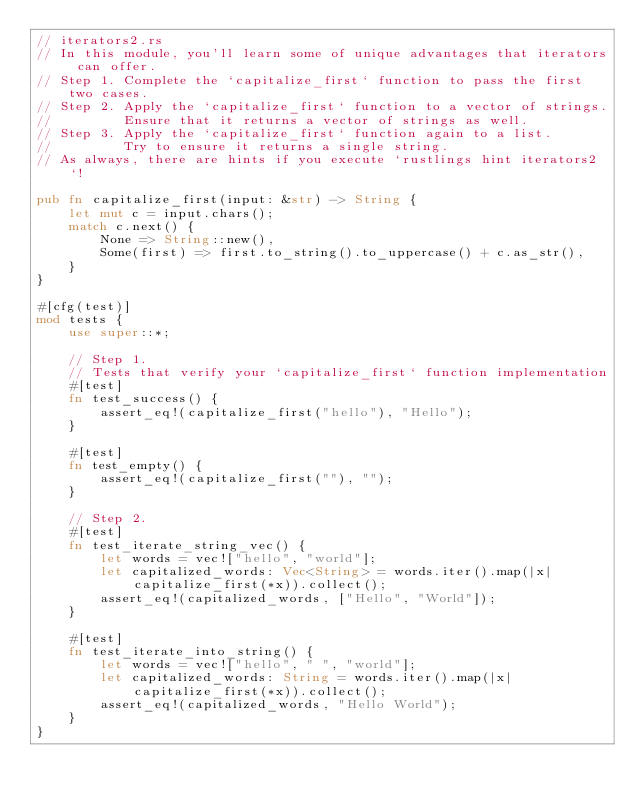Convert code to text. <code><loc_0><loc_0><loc_500><loc_500><_Rust_>// iterators2.rs
// In this module, you'll learn some of unique advantages that iterators can offer.
// Step 1. Complete the `capitalize_first` function to pass the first two cases.
// Step 2. Apply the `capitalize_first` function to a vector of strings.
//         Ensure that it returns a vector of strings as well.
// Step 3. Apply the `capitalize_first` function again to a list.
//         Try to ensure it returns a single string.
// As always, there are hints if you execute `rustlings hint iterators2`!

pub fn capitalize_first(input: &str) -> String {
    let mut c = input.chars();
    match c.next() {
        None => String::new(),
        Some(first) => first.to_string().to_uppercase() + c.as_str(),
    }
}

#[cfg(test)]
mod tests {
    use super::*;

    // Step 1.
    // Tests that verify your `capitalize_first` function implementation
    #[test]
    fn test_success() {
        assert_eq!(capitalize_first("hello"), "Hello");
    }

    #[test]
    fn test_empty() {
        assert_eq!(capitalize_first(""), "");
    }

    // Step 2.
    #[test]
    fn test_iterate_string_vec() {
        let words = vec!["hello", "world"];
        let capitalized_words: Vec<String> = words.iter().map(|x| capitalize_first(*x)).collect();
        assert_eq!(capitalized_words, ["Hello", "World"]);
    }

    #[test]
    fn test_iterate_into_string() {
        let words = vec!["hello", " ", "world"];
        let capitalized_words: String = words.iter().map(|x| capitalize_first(*x)).collect();
        assert_eq!(capitalized_words, "Hello World");
    }
}
</code> 